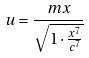<formula> <loc_0><loc_0><loc_500><loc_500>u = \frac { m x } { \sqrt { 1 \cdot \frac { x ^ { 7 } } { c ^ { 7 } } } }</formula> 